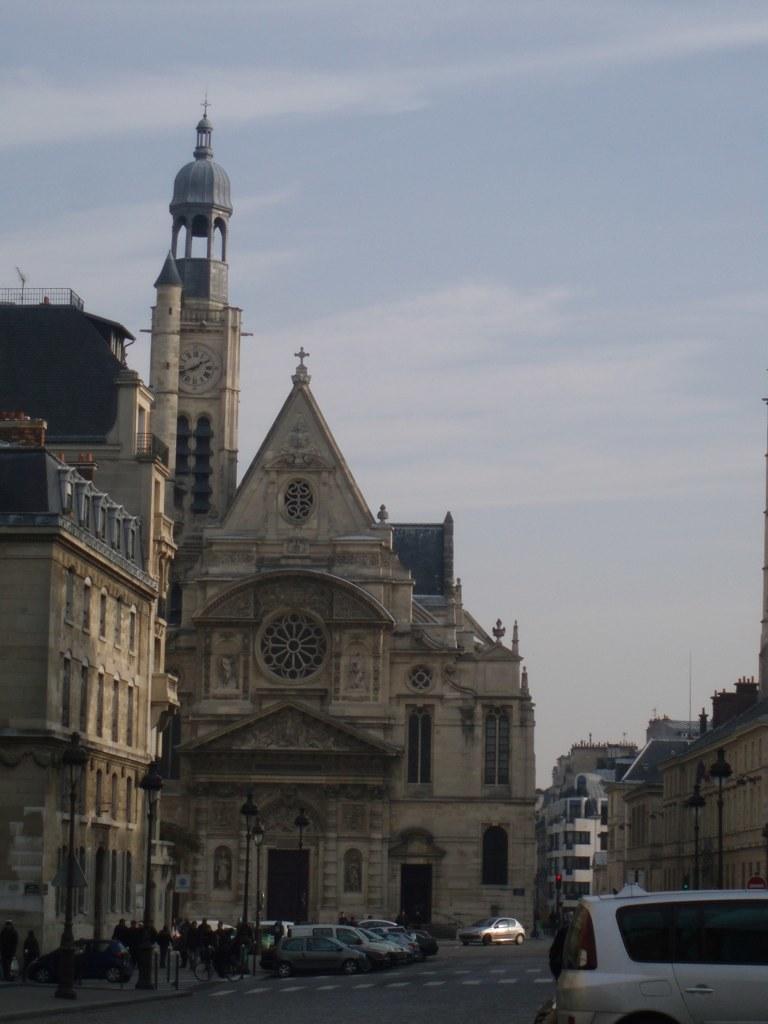In one or two sentences, can you explain what this image depicts? In this picture we can see vehicles on the road. In the background, we can see a tall building with people standing in front of it. 